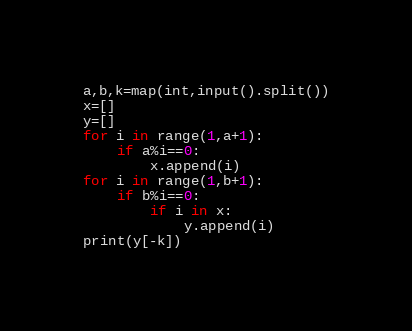Convert code to text. <code><loc_0><loc_0><loc_500><loc_500><_Python_>a,b,k=map(int,input().split())
x=[]
y=[]
for i in range(1,a+1):
    if a%i==0:
        x.append(i)
for i in range(1,b+1):
    if b%i==0:
        if i in x:
            y.append(i)
print(y[-k])
</code> 